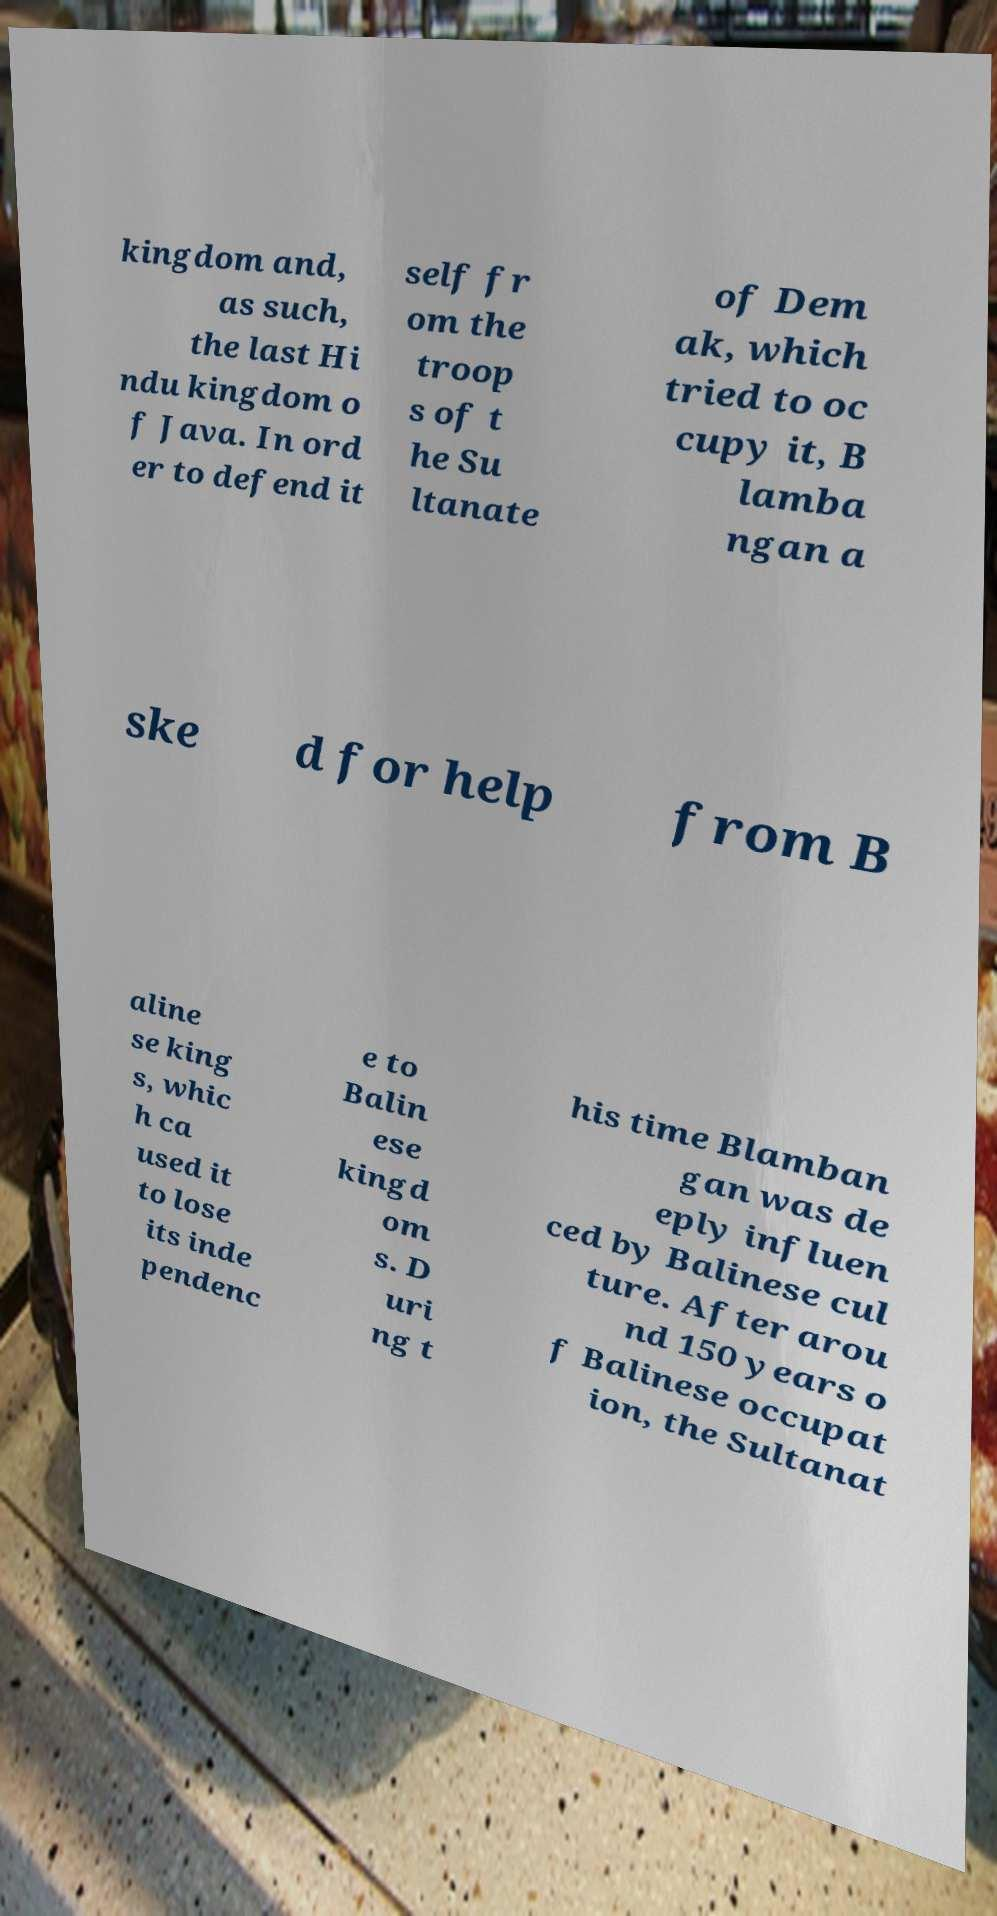I need the written content from this picture converted into text. Can you do that? kingdom and, as such, the last Hi ndu kingdom o f Java. In ord er to defend it self fr om the troop s of t he Su ltanate of Dem ak, which tried to oc cupy it, B lamba ngan a ske d for help from B aline se king s, whic h ca used it to lose its inde pendenc e to Balin ese kingd om s. D uri ng t his time Blamban gan was de eply influen ced by Balinese cul ture. After arou nd 150 years o f Balinese occupat ion, the Sultanat 